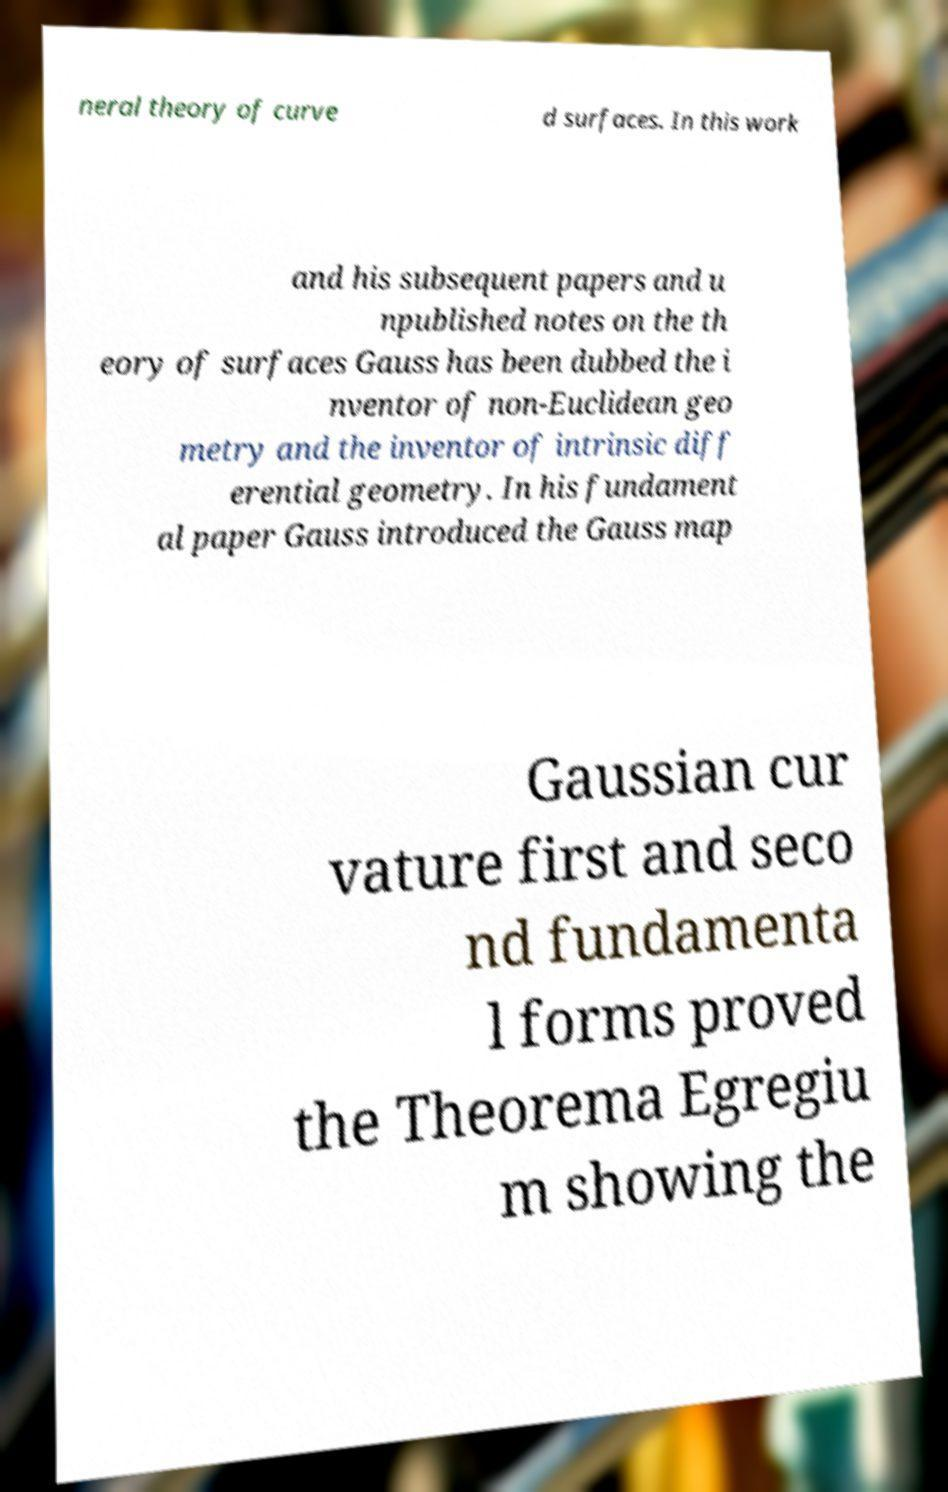Could you assist in decoding the text presented in this image and type it out clearly? neral theory of curve d surfaces. In this work and his subsequent papers and u npublished notes on the th eory of surfaces Gauss has been dubbed the i nventor of non-Euclidean geo metry and the inventor of intrinsic diff erential geometry. In his fundament al paper Gauss introduced the Gauss map Gaussian cur vature first and seco nd fundamenta l forms proved the Theorema Egregiu m showing the 